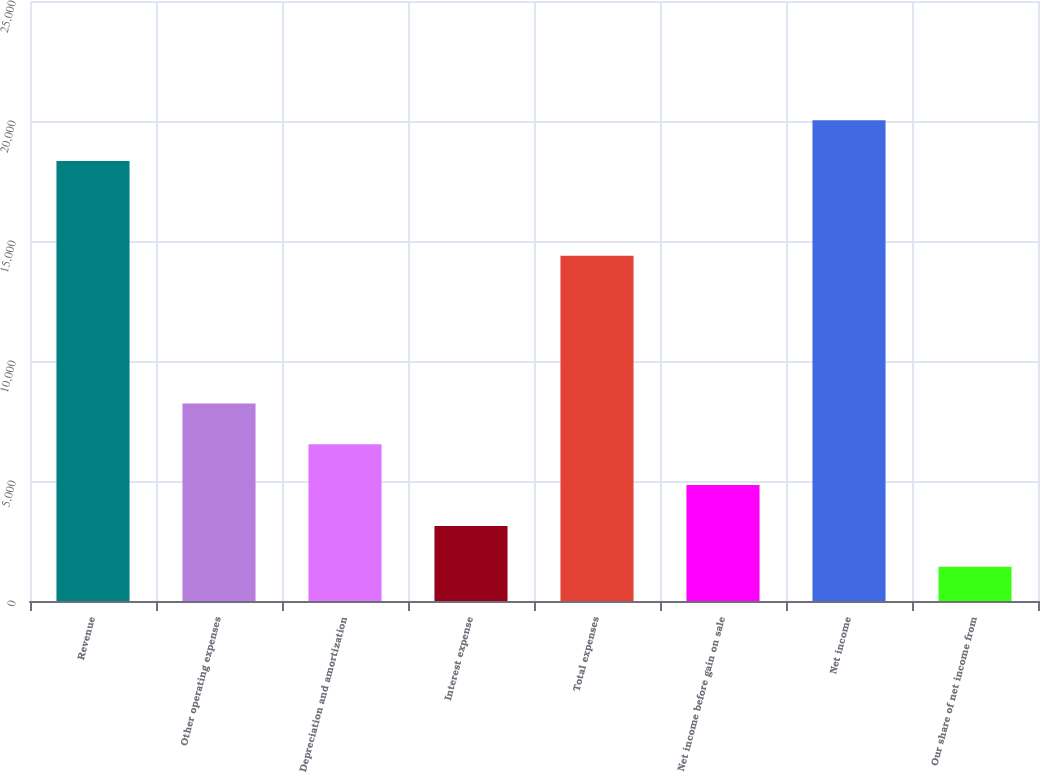<chart> <loc_0><loc_0><loc_500><loc_500><bar_chart><fcel>Revenue<fcel>Other operating expenses<fcel>Depreciation and amortization<fcel>Interest expense<fcel>Total expenses<fcel>Net income before gain on sale<fcel>Net income<fcel>Our share of net income from<nl><fcel>18329<fcel>8234.2<fcel>6531.4<fcel>3125.8<fcel>14385<fcel>4828.6<fcel>20031.8<fcel>1423<nl></chart> 